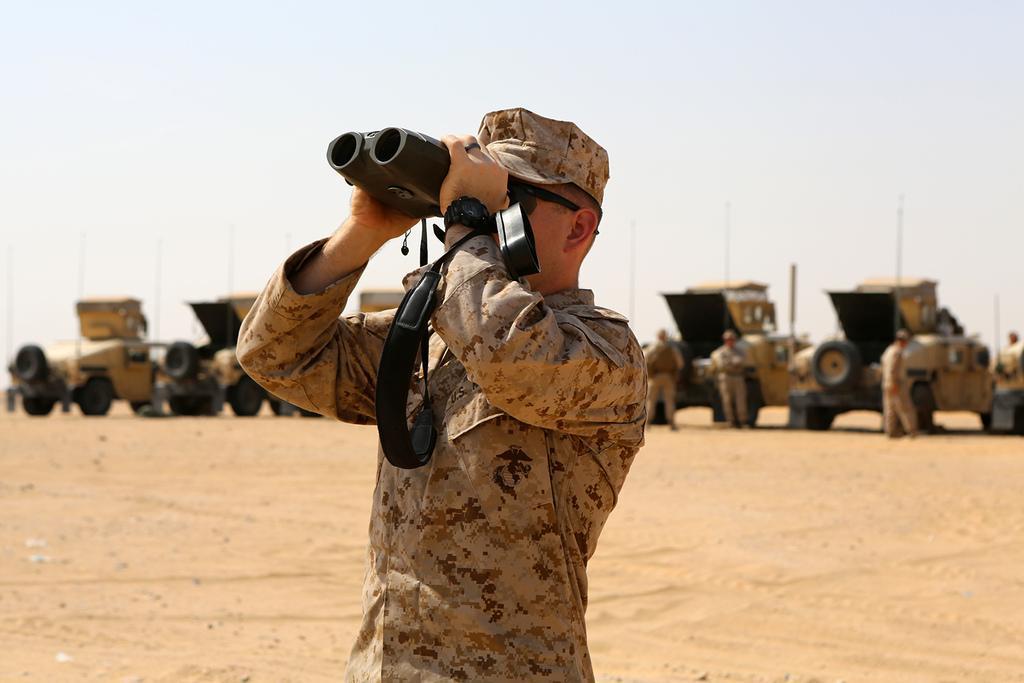Please provide a concise description of this image. In the center of the image we can see a man standing and holding binoculars. In the background there are vehicles and we can see people. At the top there is sky. 